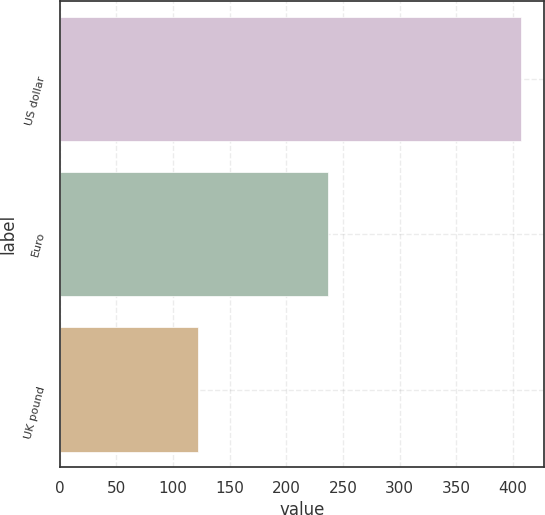Convert chart to OTSL. <chart><loc_0><loc_0><loc_500><loc_500><bar_chart><fcel>US dollar<fcel>Euro<fcel>UK pound<nl><fcel>407<fcel>237<fcel>122<nl></chart> 